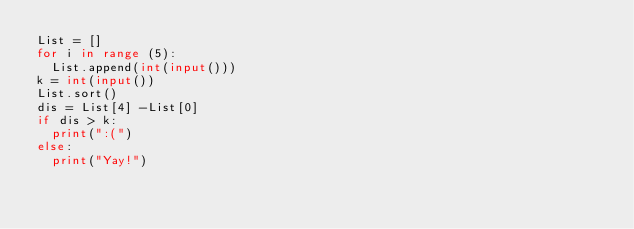<code> <loc_0><loc_0><loc_500><loc_500><_Python_>List = []
for i in range (5):
  List.append(int(input()))
k = int(input())
List.sort()
dis = List[4] -List[0]
if dis > k:
  print(":(")
else:
  print("Yay!")</code> 